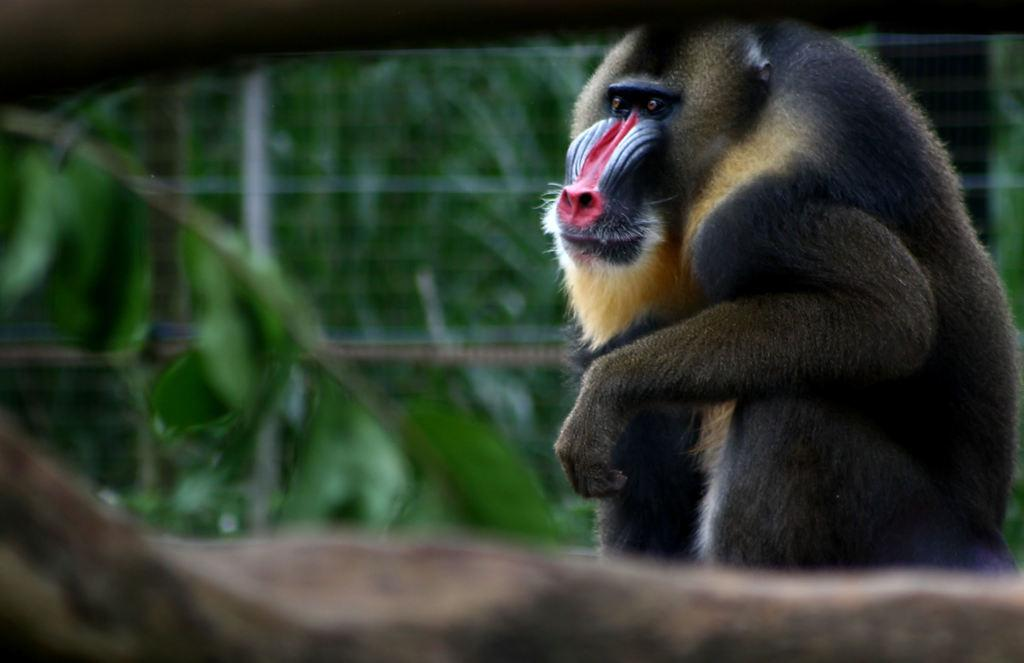What animal is the main subject of the image? There is a baboon in the image. Can you describe the background of the image? The background of the image is blurred. What type of dress is the owl wearing in the image? There is no owl or dress present in the image; it features a baboon with a blurred background. 